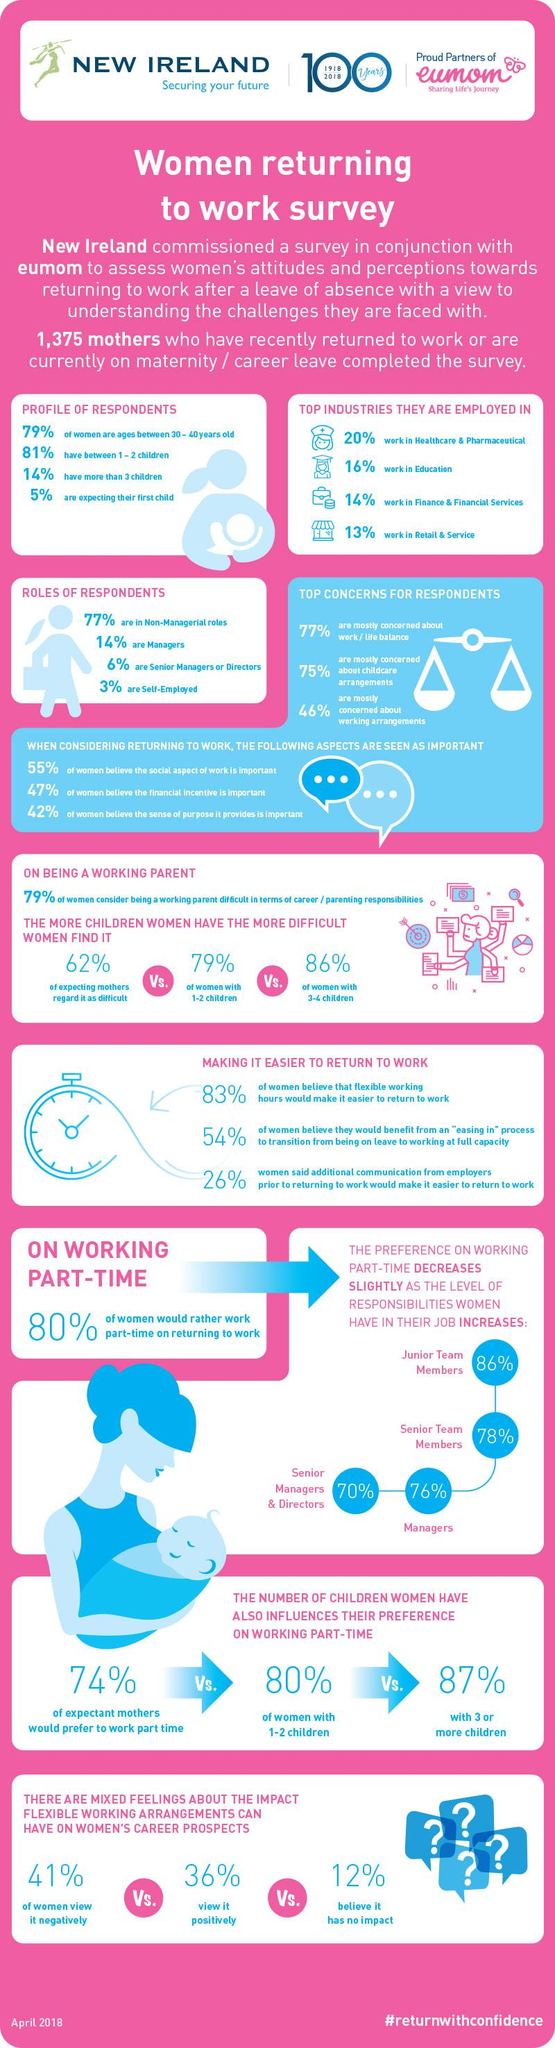Highlight a few significant elements in this photo. According to the survey, only 3% of respondents work independently. According to the survey, 20% of the respondents are managers, senior managers, or directors. The given hashtag is "#returnwithconfidence. The healthcare and pharmaceutical industry has the highest number of mothers working within it. 